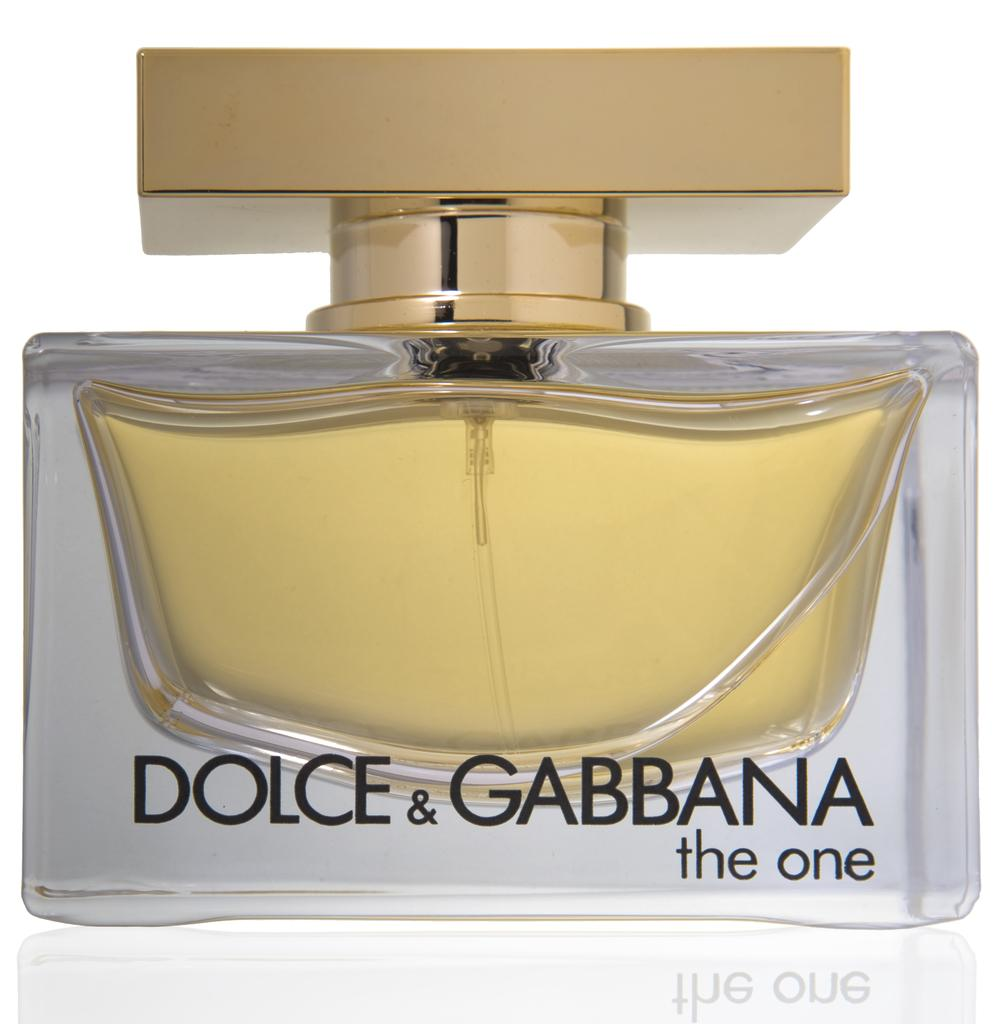<image>
Share a concise interpretation of the image provided. the word dolce is on the back of some cologne 